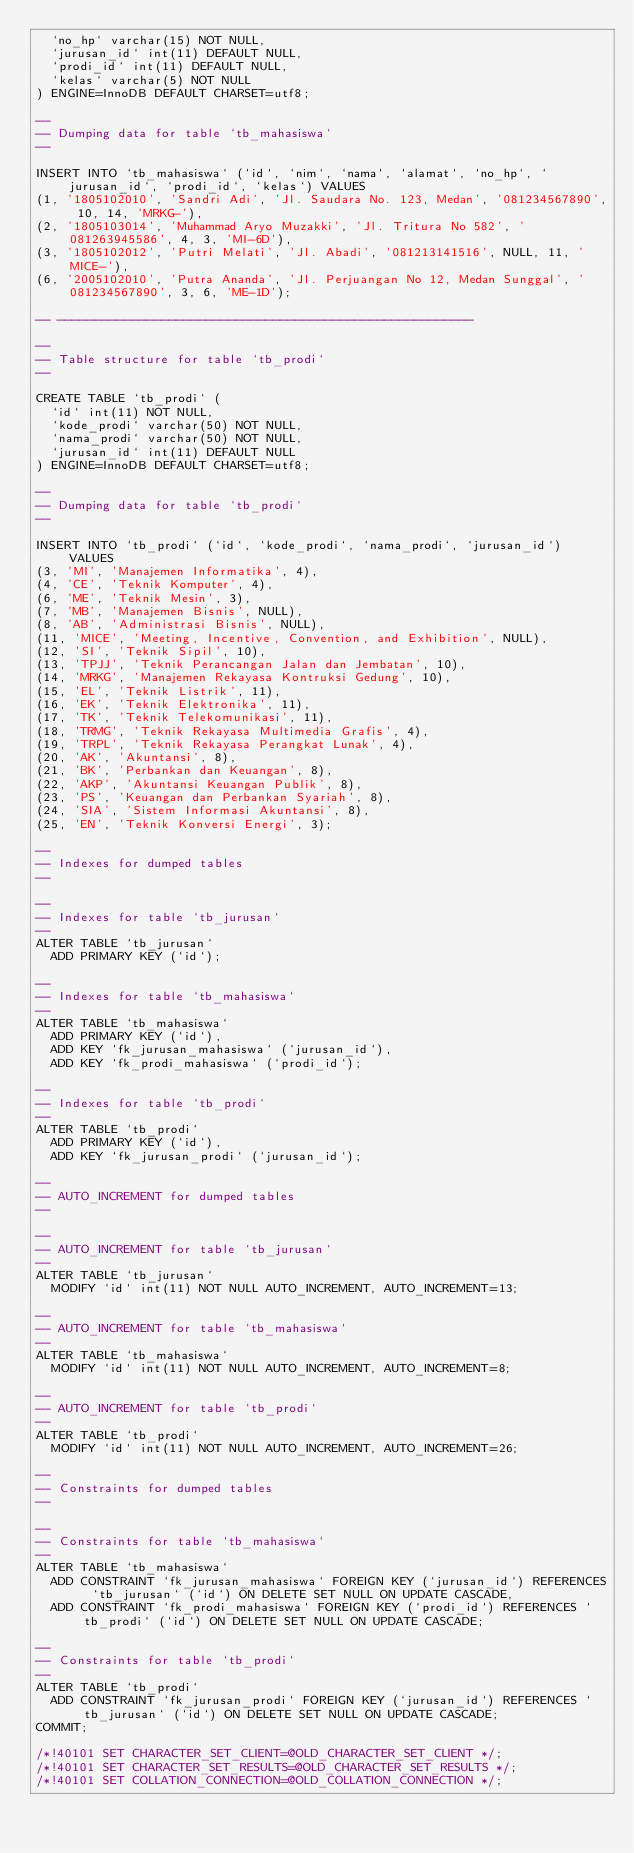Convert code to text. <code><loc_0><loc_0><loc_500><loc_500><_SQL_>  `no_hp` varchar(15) NOT NULL,
  `jurusan_id` int(11) DEFAULT NULL,
  `prodi_id` int(11) DEFAULT NULL,
  `kelas` varchar(5) NOT NULL
) ENGINE=InnoDB DEFAULT CHARSET=utf8;

--
-- Dumping data for table `tb_mahasiswa`
--

INSERT INTO `tb_mahasiswa` (`id`, `nim`, `nama`, `alamat`, `no_hp`, `jurusan_id`, `prodi_id`, `kelas`) VALUES
(1, '1805102010', 'Sandri Adi', 'Jl. Saudara No. 123, Medan', '081234567890', 10, 14, 'MRKG-'),
(2, '1805103014', 'Muhammad Aryo Muzakki', 'Jl. Tritura No 582', '081263945586', 4, 3, 'MI-6D'),
(3, '1805102012', 'Putri Melati', 'Jl. Abadi', '081213141516', NULL, 11, 'MICE-'),
(6, '2005102010', 'Putra Ananda', 'Jl. Perjuangan No 12, Medan Sunggal', '081234567890', 3, 6, 'ME-1D');

-- --------------------------------------------------------

--
-- Table structure for table `tb_prodi`
--

CREATE TABLE `tb_prodi` (
  `id` int(11) NOT NULL,
  `kode_prodi` varchar(50) NOT NULL,
  `nama_prodi` varchar(50) NOT NULL,
  `jurusan_id` int(11) DEFAULT NULL
) ENGINE=InnoDB DEFAULT CHARSET=utf8;

--
-- Dumping data for table `tb_prodi`
--

INSERT INTO `tb_prodi` (`id`, `kode_prodi`, `nama_prodi`, `jurusan_id`) VALUES
(3, 'MI', 'Manajemen Informatika', 4),
(4, 'CE', 'Teknik Komputer', 4),
(6, 'ME', 'Teknik Mesin', 3),
(7, 'MB', 'Manajemen Bisnis', NULL),
(8, 'AB', 'Administrasi Bisnis', NULL),
(11, 'MICE', 'Meeting, Incentive, Convention, and Exhibition', NULL),
(12, 'SI', 'Teknik Sipil', 10),
(13, 'TPJJ', 'Teknik Perancangan Jalan dan Jembatan', 10),
(14, 'MRKG', 'Manajemen Rekayasa Kontruksi Gedung', 10),
(15, 'EL', 'Teknik Listrik', 11),
(16, 'EK', 'Teknik Elektronika', 11),
(17, 'TK', 'Teknik Telekomunikasi', 11),
(18, 'TRMG', 'Teknik Rekayasa Multimedia Grafis', 4),
(19, 'TRPL', 'Teknik Rekayasa Perangkat Lunak', 4),
(20, 'AK', 'Akuntansi', 8),
(21, 'BK', 'Perbankan dan Keuangan', 8),
(22, 'AKP', 'Akuntansi Keuangan Publik', 8),
(23, 'PS', 'Keuangan dan Perbankan Syariah', 8),
(24, 'SIA', 'Sistem Informasi Akuntansi', 8),
(25, 'EN', 'Teknik Konversi Energi', 3);

--
-- Indexes for dumped tables
--

--
-- Indexes for table `tb_jurusan`
--
ALTER TABLE `tb_jurusan`
  ADD PRIMARY KEY (`id`);

--
-- Indexes for table `tb_mahasiswa`
--
ALTER TABLE `tb_mahasiswa`
  ADD PRIMARY KEY (`id`),
  ADD KEY `fk_jurusan_mahasiswa` (`jurusan_id`),
  ADD KEY `fk_prodi_mahasiswa` (`prodi_id`);

--
-- Indexes for table `tb_prodi`
--
ALTER TABLE `tb_prodi`
  ADD PRIMARY KEY (`id`),
  ADD KEY `fk_jurusan_prodi` (`jurusan_id`);

--
-- AUTO_INCREMENT for dumped tables
--

--
-- AUTO_INCREMENT for table `tb_jurusan`
--
ALTER TABLE `tb_jurusan`
  MODIFY `id` int(11) NOT NULL AUTO_INCREMENT, AUTO_INCREMENT=13;

--
-- AUTO_INCREMENT for table `tb_mahasiswa`
--
ALTER TABLE `tb_mahasiswa`
  MODIFY `id` int(11) NOT NULL AUTO_INCREMENT, AUTO_INCREMENT=8;

--
-- AUTO_INCREMENT for table `tb_prodi`
--
ALTER TABLE `tb_prodi`
  MODIFY `id` int(11) NOT NULL AUTO_INCREMENT, AUTO_INCREMENT=26;

--
-- Constraints for dumped tables
--

--
-- Constraints for table `tb_mahasiswa`
--
ALTER TABLE `tb_mahasiswa`
  ADD CONSTRAINT `fk_jurusan_mahasiswa` FOREIGN KEY (`jurusan_id`) REFERENCES `tb_jurusan` (`id`) ON DELETE SET NULL ON UPDATE CASCADE,
  ADD CONSTRAINT `fk_prodi_mahasiswa` FOREIGN KEY (`prodi_id`) REFERENCES `tb_prodi` (`id`) ON DELETE SET NULL ON UPDATE CASCADE;

--
-- Constraints for table `tb_prodi`
--
ALTER TABLE `tb_prodi`
  ADD CONSTRAINT `fk_jurusan_prodi` FOREIGN KEY (`jurusan_id`) REFERENCES `tb_jurusan` (`id`) ON DELETE SET NULL ON UPDATE CASCADE;
COMMIT;

/*!40101 SET CHARACTER_SET_CLIENT=@OLD_CHARACTER_SET_CLIENT */;
/*!40101 SET CHARACTER_SET_RESULTS=@OLD_CHARACTER_SET_RESULTS */;
/*!40101 SET COLLATION_CONNECTION=@OLD_COLLATION_CONNECTION */;
</code> 